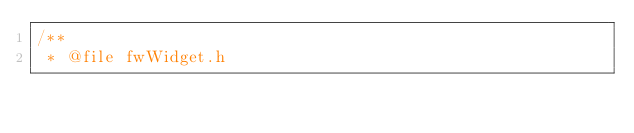<code> <loc_0><loc_0><loc_500><loc_500><_C_>/**
 * @file fwWidget.h</code> 